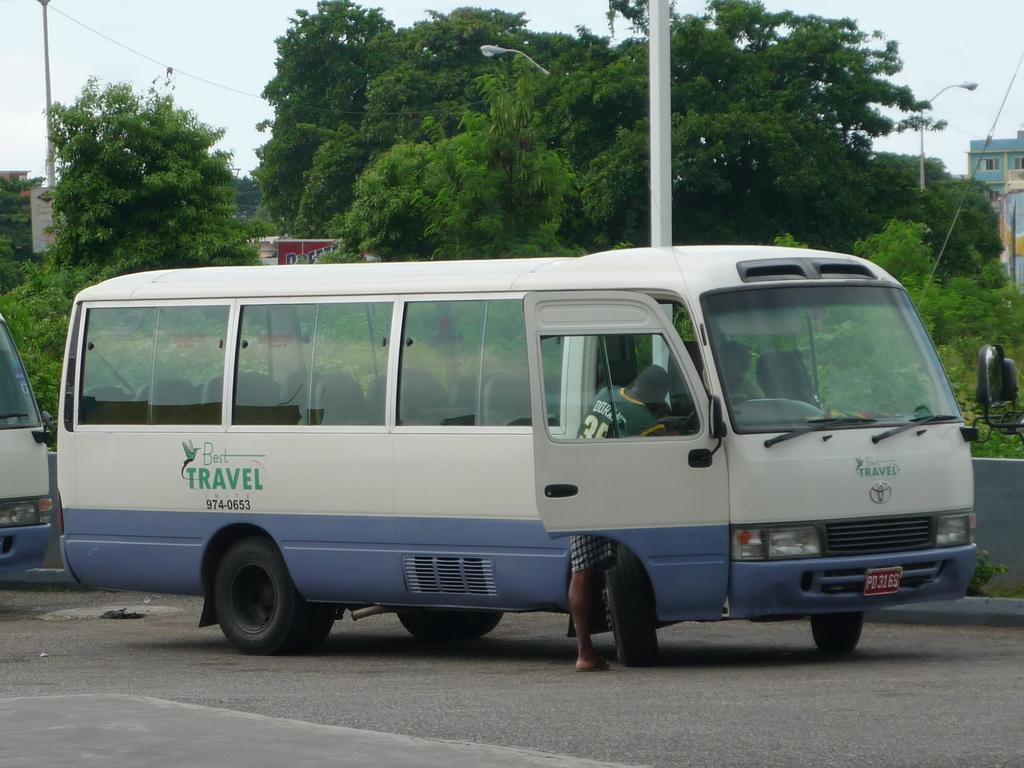Provide a one-sentence caption for the provided image. A white and blue shuttle bus for Best Travel. 